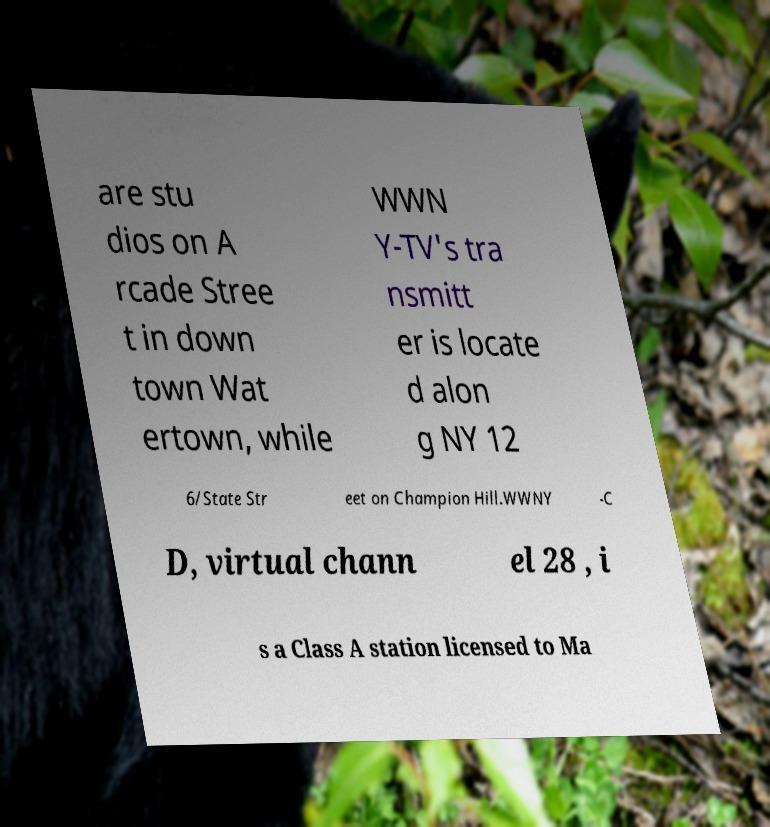Can you accurately transcribe the text from the provided image for me? are stu dios on A rcade Stree t in down town Wat ertown, while WWN Y-TV's tra nsmitt er is locate d alon g NY 12 6/State Str eet on Champion Hill.WWNY -C D, virtual chann el 28 , i s a Class A station licensed to Ma 